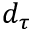<formula> <loc_0><loc_0><loc_500><loc_500>d _ { \tau }</formula> 